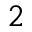<formula> <loc_0><loc_0><loc_500><loc_500>^ { 2 }</formula> 